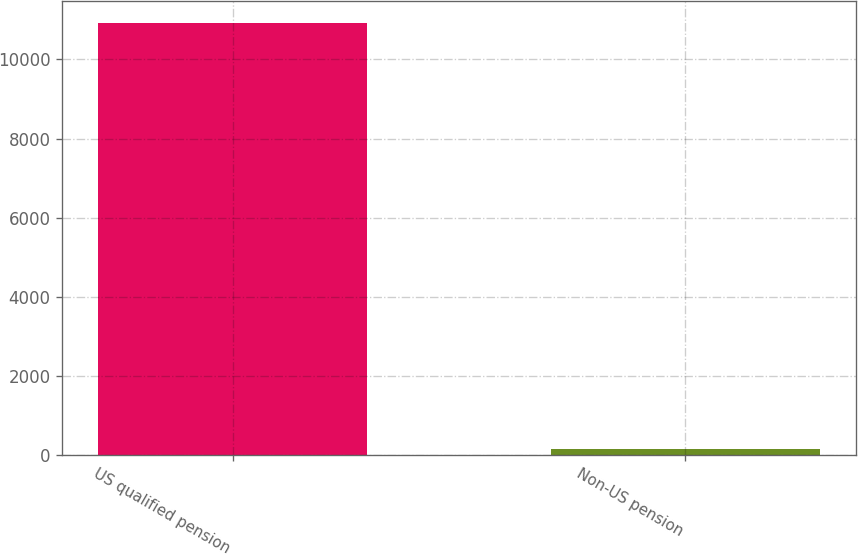Convert chart. <chart><loc_0><loc_0><loc_500><loc_500><bar_chart><fcel>US qualified pension<fcel>Non-US pension<nl><fcel>10923<fcel>155<nl></chart> 